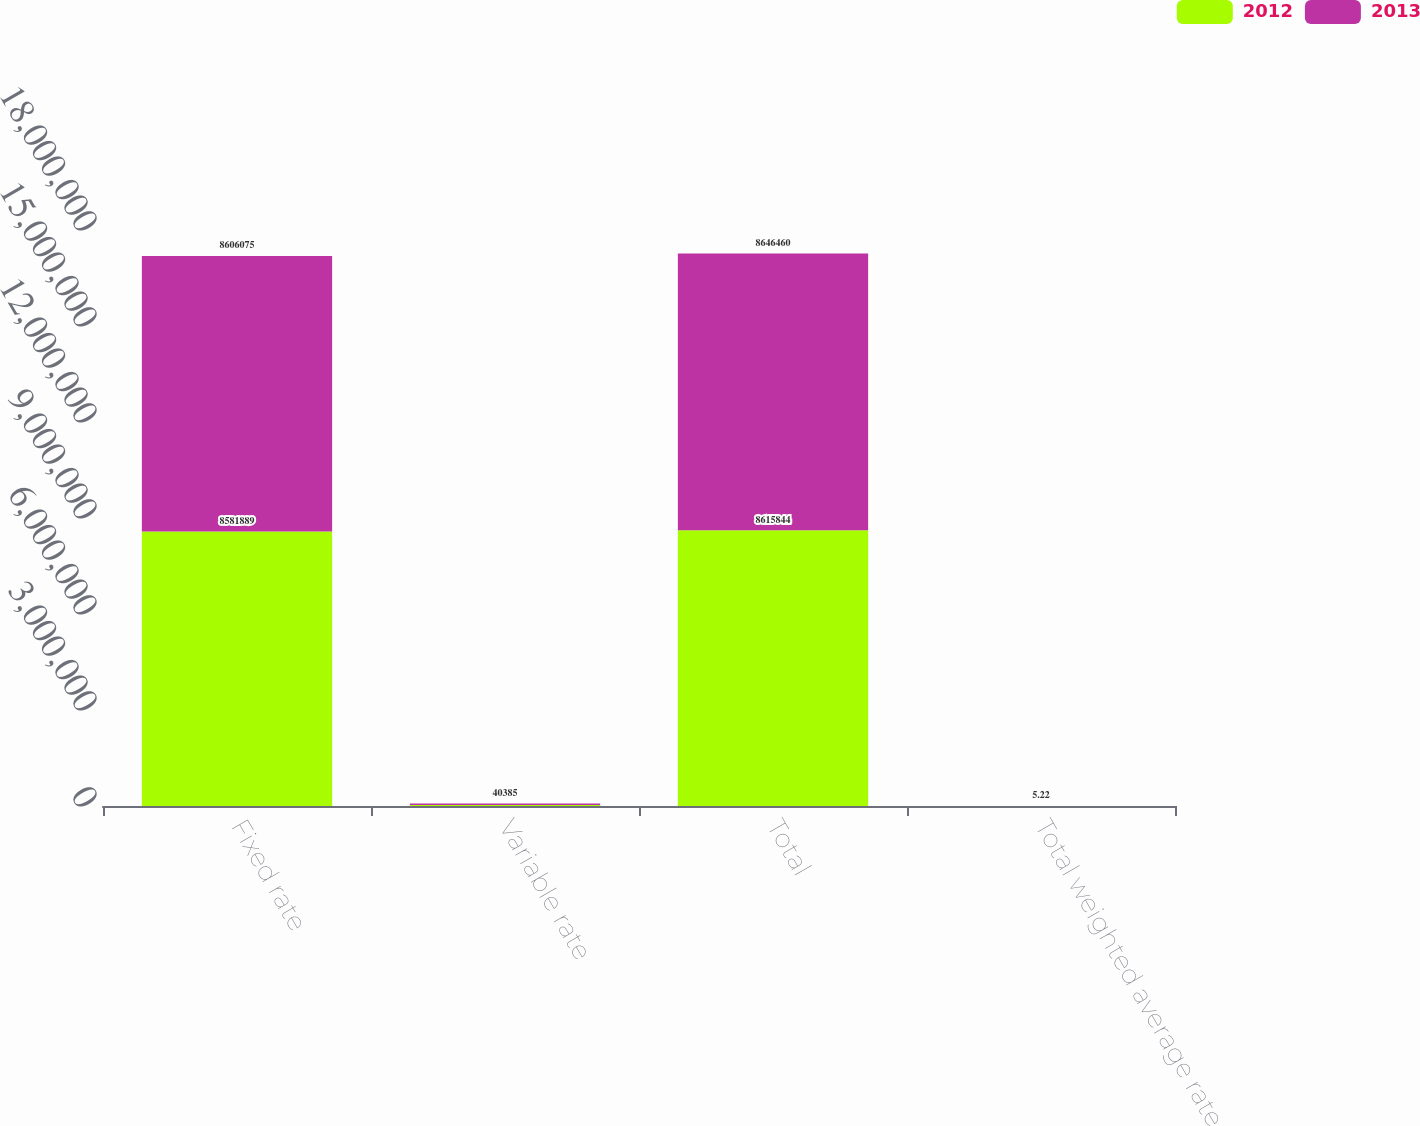Convert chart to OTSL. <chart><loc_0><loc_0><loc_500><loc_500><stacked_bar_chart><ecel><fcel>Fixed rate<fcel>Variable rate<fcel>Total<fcel>Total weighted average rate<nl><fcel>2012<fcel>8.58189e+06<fcel>33955<fcel>8.61584e+06<fcel>5.08<nl><fcel>2013<fcel>8.60608e+06<fcel>40385<fcel>8.64646e+06<fcel>5.22<nl></chart> 